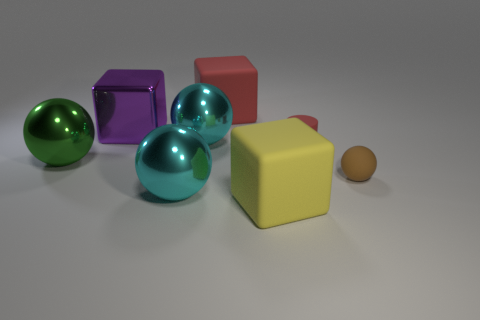Subtract all cyan balls. How many were subtracted if there are1cyan balls left? 1 Add 2 red matte objects. How many objects exist? 10 Subtract all big yellow rubber cubes. How many cubes are left? 2 Add 3 big red matte spheres. How many big red matte spheres exist? 3 Subtract all yellow cubes. How many cubes are left? 2 Subtract 0 gray blocks. How many objects are left? 8 Subtract all blocks. How many objects are left? 5 Subtract 2 cubes. How many cubes are left? 1 Subtract all brown spheres. Subtract all yellow cubes. How many spheres are left? 3 Subtract all cyan cubes. How many gray spheres are left? 0 